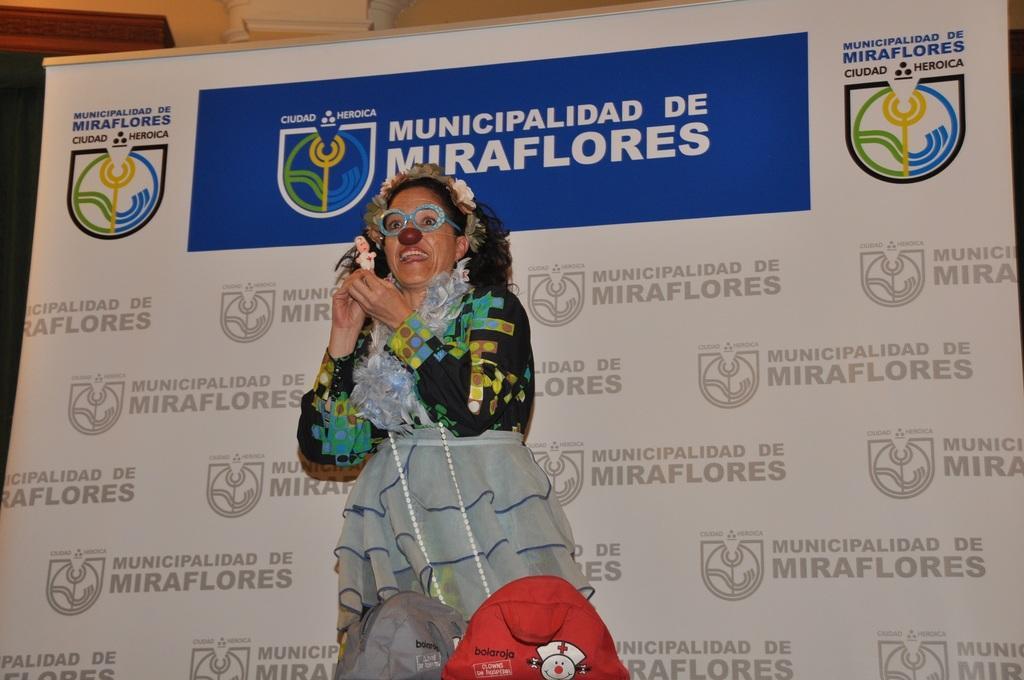In one or two sentences, can you explain what this image depicts? In this picture we can see a woman, she is holding a toy, here we can see a banner and some objects. 